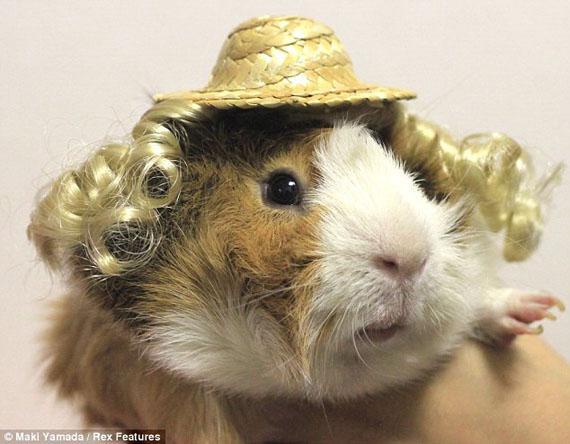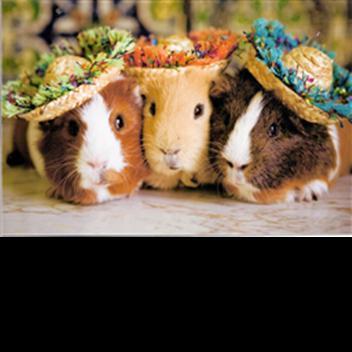The first image is the image on the left, the second image is the image on the right. Evaluate the accuracy of this statement regarding the images: "Each image shows exactly three guinea pigs posed tightly together side-by-side.". Is it true? Answer yes or no. No. The first image is the image on the left, the second image is the image on the right. Evaluate the accuracy of this statement regarding the images: "There are six mammals huddled in groups of three.". Is it true? Answer yes or no. No. 